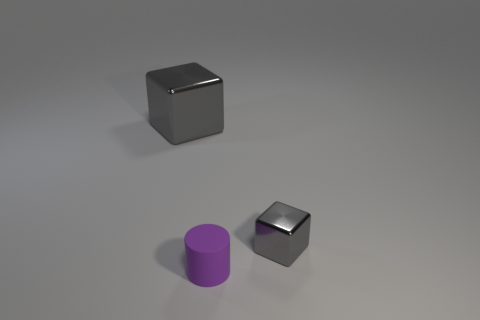Add 1 blue metallic blocks. How many objects exist? 4 Subtract all cubes. How many objects are left? 1 Add 3 small objects. How many small objects are left? 5 Add 1 big blue metallic objects. How many big blue metallic objects exist? 1 Subtract 0 cyan balls. How many objects are left? 3 Subtract all purple matte things. Subtract all blue matte cylinders. How many objects are left? 2 